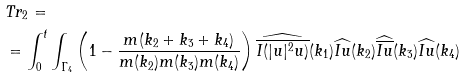Convert formula to latex. <formula><loc_0><loc_0><loc_500><loc_500>& T r _ { 2 } = \\ & = \int _ { 0 } ^ { t } \int _ { \Gamma _ { 4 } } \left ( 1 - \frac { m ( k _ { 2 } + k _ { 3 } + k _ { 4 } ) } { m ( k _ { 2 } ) m ( k _ { 3 } ) m ( k _ { 4 } ) } \right ) \widehat { \overline { I ( | u | ^ { 2 } u ) } } ( k _ { 1 } ) \widehat { I u } ( k _ { 2 } ) \widehat { \overline { I u } } ( k _ { 3 } ) \widehat { I u } ( k _ { 4 } )</formula> 